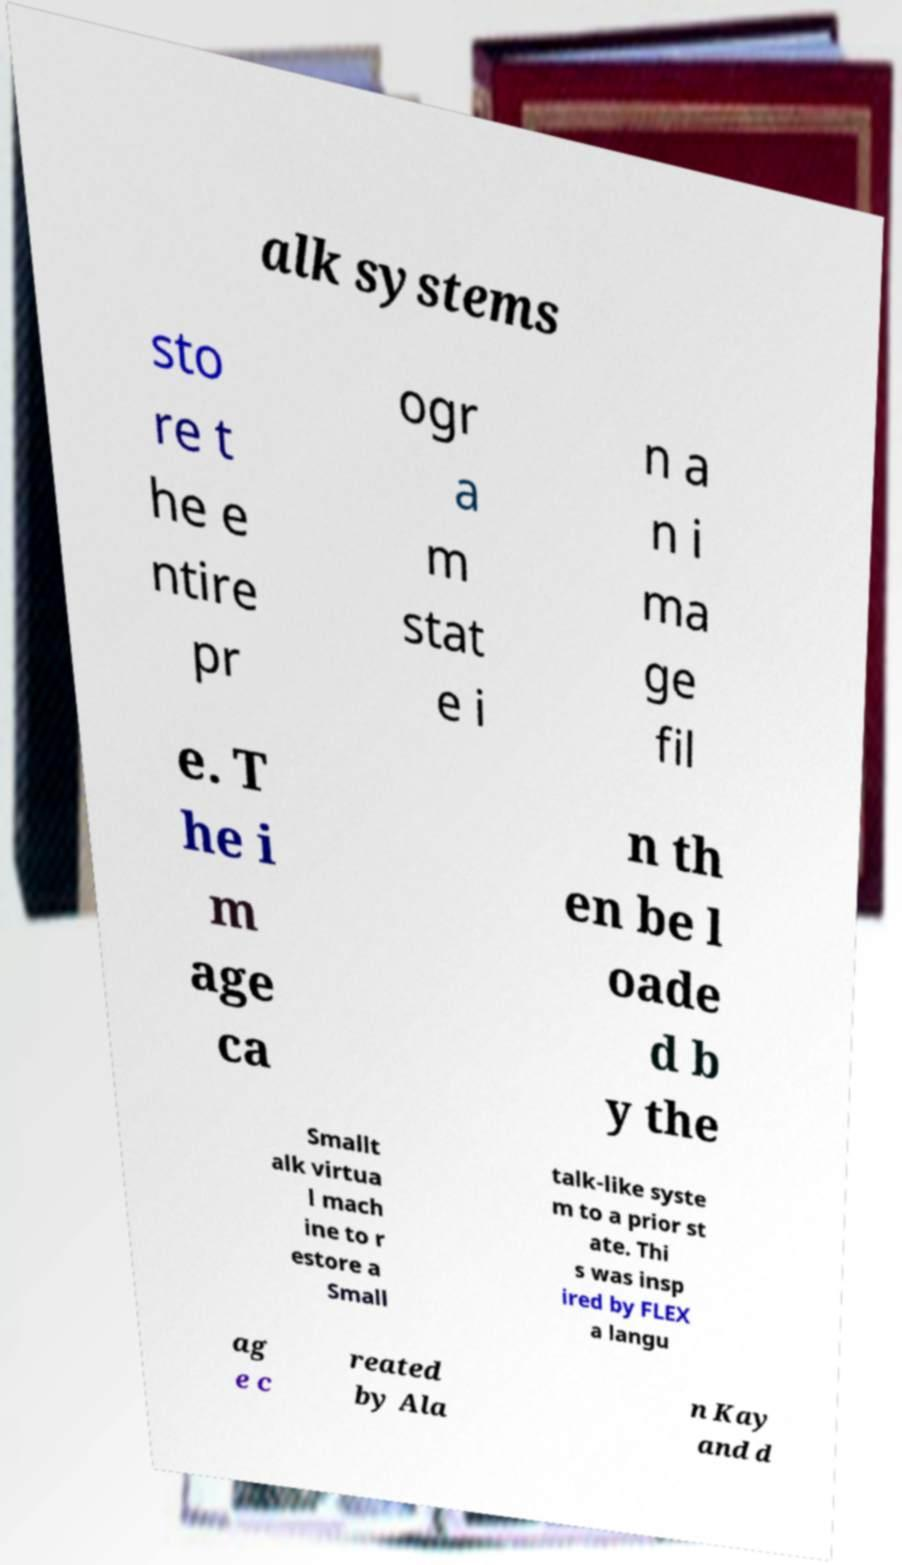What messages or text are displayed in this image? I need them in a readable, typed format. alk systems sto re t he e ntire pr ogr a m stat e i n a n i ma ge fil e. T he i m age ca n th en be l oade d b y the Smallt alk virtua l mach ine to r estore a Small talk-like syste m to a prior st ate. Thi s was insp ired by FLEX a langu ag e c reated by Ala n Kay and d 